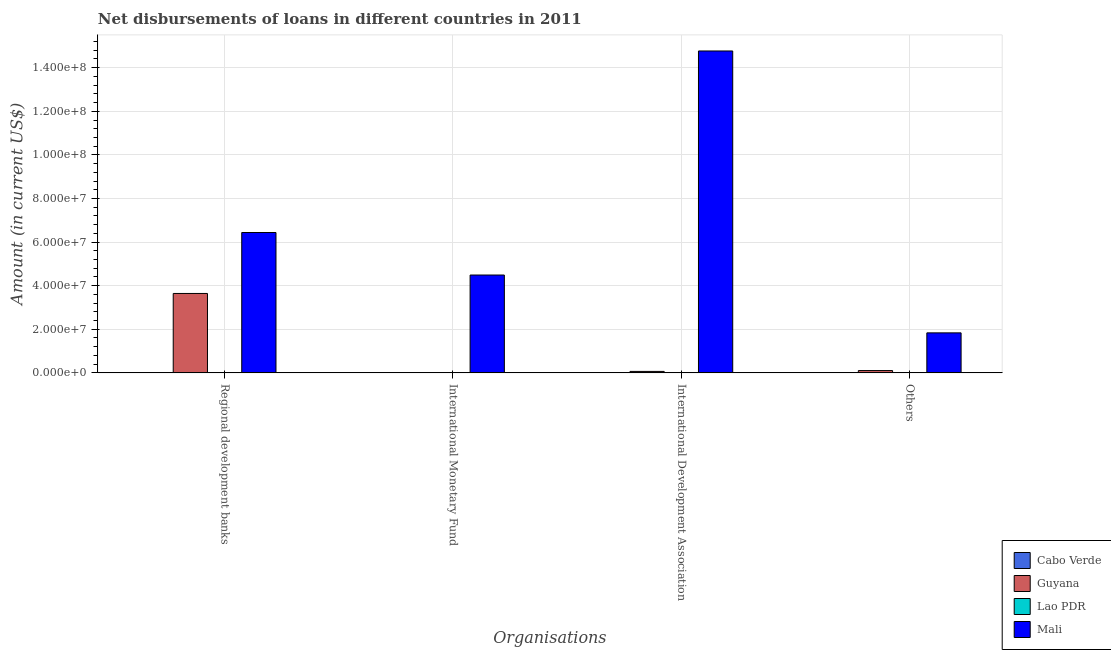How many bars are there on the 3rd tick from the left?
Offer a terse response. 2. How many bars are there on the 3rd tick from the right?
Your answer should be compact. 1. What is the label of the 1st group of bars from the left?
Provide a short and direct response. Regional development banks. What is the amount of loan disimbursed by international monetary fund in Lao PDR?
Your answer should be very brief. 0. Across all countries, what is the maximum amount of loan disimbursed by regional development banks?
Ensure brevity in your answer.  6.44e+07. Across all countries, what is the minimum amount of loan disimbursed by other organisations?
Offer a very short reply. 0. In which country was the amount of loan disimbursed by other organisations maximum?
Make the answer very short. Mali. What is the total amount of loan disimbursed by other organisations in the graph?
Your answer should be very brief. 1.94e+07. What is the difference between the amount of loan disimbursed by other organisations in Cabo Verde and the amount of loan disimbursed by international development association in Guyana?
Your answer should be compact. -6.68e+05. What is the average amount of loan disimbursed by international monetary fund per country?
Ensure brevity in your answer.  1.12e+07. What is the difference between the amount of loan disimbursed by regional development banks and amount of loan disimbursed by international monetary fund in Mali?
Keep it short and to the point. 1.95e+07. In how many countries, is the amount of loan disimbursed by other organisations greater than 132000000 US$?
Provide a succinct answer. 0. What is the difference between the highest and the lowest amount of loan disimbursed by regional development banks?
Your response must be concise. 6.44e+07. In how many countries, is the amount of loan disimbursed by regional development banks greater than the average amount of loan disimbursed by regional development banks taken over all countries?
Offer a very short reply. 2. What is the difference between two consecutive major ticks on the Y-axis?
Your response must be concise. 2.00e+07. Are the values on the major ticks of Y-axis written in scientific E-notation?
Make the answer very short. Yes. Does the graph contain any zero values?
Your answer should be compact. Yes. Where does the legend appear in the graph?
Give a very brief answer. Bottom right. How are the legend labels stacked?
Ensure brevity in your answer.  Vertical. What is the title of the graph?
Make the answer very short. Net disbursements of loans in different countries in 2011. Does "Korea (Republic)" appear as one of the legend labels in the graph?
Give a very brief answer. No. What is the label or title of the X-axis?
Your response must be concise. Organisations. What is the Amount (in current US$) of Guyana in Regional development banks?
Keep it short and to the point. 3.64e+07. What is the Amount (in current US$) of Mali in Regional development banks?
Make the answer very short. 6.44e+07. What is the Amount (in current US$) in Cabo Verde in International Monetary Fund?
Your answer should be compact. 0. What is the Amount (in current US$) in Lao PDR in International Monetary Fund?
Offer a very short reply. 0. What is the Amount (in current US$) in Mali in International Monetary Fund?
Ensure brevity in your answer.  4.49e+07. What is the Amount (in current US$) in Cabo Verde in International Development Association?
Make the answer very short. 0. What is the Amount (in current US$) of Guyana in International Development Association?
Your answer should be very brief. 6.68e+05. What is the Amount (in current US$) in Mali in International Development Association?
Keep it short and to the point. 1.48e+08. What is the Amount (in current US$) in Guyana in Others?
Ensure brevity in your answer.  1.06e+06. What is the Amount (in current US$) in Mali in Others?
Provide a short and direct response. 1.84e+07. Across all Organisations, what is the maximum Amount (in current US$) of Guyana?
Your response must be concise. 3.64e+07. Across all Organisations, what is the maximum Amount (in current US$) in Mali?
Your response must be concise. 1.48e+08. Across all Organisations, what is the minimum Amount (in current US$) in Guyana?
Ensure brevity in your answer.  0. Across all Organisations, what is the minimum Amount (in current US$) of Mali?
Your answer should be very brief. 1.84e+07. What is the total Amount (in current US$) in Cabo Verde in the graph?
Keep it short and to the point. 0. What is the total Amount (in current US$) of Guyana in the graph?
Make the answer very short. 3.82e+07. What is the total Amount (in current US$) of Lao PDR in the graph?
Make the answer very short. 0. What is the total Amount (in current US$) in Mali in the graph?
Make the answer very short. 2.75e+08. What is the difference between the Amount (in current US$) of Mali in Regional development banks and that in International Monetary Fund?
Your answer should be very brief. 1.95e+07. What is the difference between the Amount (in current US$) in Guyana in Regional development banks and that in International Development Association?
Make the answer very short. 3.58e+07. What is the difference between the Amount (in current US$) of Mali in Regional development banks and that in International Development Association?
Your answer should be very brief. -8.33e+07. What is the difference between the Amount (in current US$) of Guyana in Regional development banks and that in Others?
Offer a terse response. 3.54e+07. What is the difference between the Amount (in current US$) of Mali in Regional development banks and that in Others?
Your answer should be compact. 4.60e+07. What is the difference between the Amount (in current US$) of Mali in International Monetary Fund and that in International Development Association?
Make the answer very short. -1.03e+08. What is the difference between the Amount (in current US$) in Mali in International Monetary Fund and that in Others?
Offer a very short reply. 2.65e+07. What is the difference between the Amount (in current US$) of Guyana in International Development Association and that in Others?
Make the answer very short. -3.96e+05. What is the difference between the Amount (in current US$) of Mali in International Development Association and that in Others?
Give a very brief answer. 1.29e+08. What is the difference between the Amount (in current US$) of Guyana in Regional development banks and the Amount (in current US$) of Mali in International Monetary Fund?
Your answer should be very brief. -8.46e+06. What is the difference between the Amount (in current US$) in Guyana in Regional development banks and the Amount (in current US$) in Mali in International Development Association?
Keep it short and to the point. -1.11e+08. What is the difference between the Amount (in current US$) of Guyana in Regional development banks and the Amount (in current US$) of Mali in Others?
Your answer should be compact. 1.81e+07. What is the difference between the Amount (in current US$) of Guyana in International Development Association and the Amount (in current US$) of Mali in Others?
Keep it short and to the point. -1.77e+07. What is the average Amount (in current US$) in Guyana per Organisations?
Your response must be concise. 9.54e+06. What is the average Amount (in current US$) of Mali per Organisations?
Make the answer very short. 6.88e+07. What is the difference between the Amount (in current US$) of Guyana and Amount (in current US$) of Mali in Regional development banks?
Offer a terse response. -2.80e+07. What is the difference between the Amount (in current US$) of Guyana and Amount (in current US$) of Mali in International Development Association?
Give a very brief answer. -1.47e+08. What is the difference between the Amount (in current US$) of Guyana and Amount (in current US$) of Mali in Others?
Give a very brief answer. -1.73e+07. What is the ratio of the Amount (in current US$) of Mali in Regional development banks to that in International Monetary Fund?
Your response must be concise. 1.43. What is the ratio of the Amount (in current US$) of Guyana in Regional development banks to that in International Development Association?
Provide a succinct answer. 54.53. What is the ratio of the Amount (in current US$) of Mali in Regional development banks to that in International Development Association?
Make the answer very short. 0.44. What is the ratio of the Amount (in current US$) in Guyana in Regional development banks to that in Others?
Provide a short and direct response. 34.24. What is the ratio of the Amount (in current US$) in Mali in Regional development banks to that in Others?
Offer a terse response. 3.51. What is the ratio of the Amount (in current US$) in Mali in International Monetary Fund to that in International Development Association?
Your answer should be compact. 0.3. What is the ratio of the Amount (in current US$) of Mali in International Monetary Fund to that in Others?
Make the answer very short. 2.45. What is the ratio of the Amount (in current US$) of Guyana in International Development Association to that in Others?
Give a very brief answer. 0.63. What is the ratio of the Amount (in current US$) in Mali in International Development Association to that in Others?
Offer a very short reply. 8.05. What is the difference between the highest and the second highest Amount (in current US$) in Guyana?
Keep it short and to the point. 3.54e+07. What is the difference between the highest and the second highest Amount (in current US$) of Mali?
Provide a succinct answer. 8.33e+07. What is the difference between the highest and the lowest Amount (in current US$) of Guyana?
Provide a short and direct response. 3.64e+07. What is the difference between the highest and the lowest Amount (in current US$) of Mali?
Offer a terse response. 1.29e+08. 